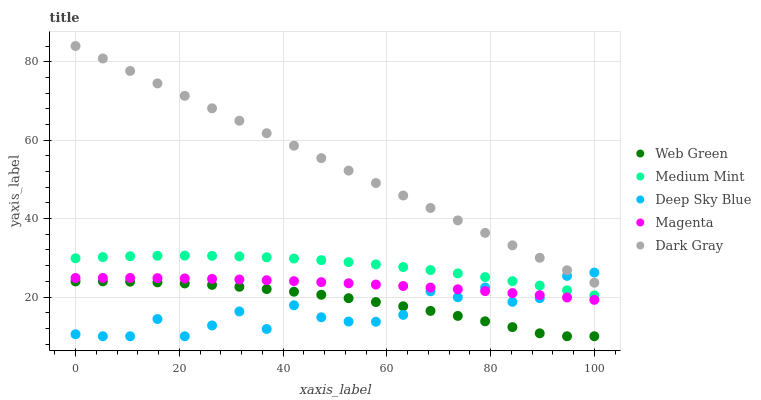Does Deep Sky Blue have the minimum area under the curve?
Answer yes or no. Yes. Does Dark Gray have the maximum area under the curve?
Answer yes or no. Yes. Does Magenta have the minimum area under the curve?
Answer yes or no. No. Does Magenta have the maximum area under the curve?
Answer yes or no. No. Is Dark Gray the smoothest?
Answer yes or no. Yes. Is Deep Sky Blue the roughest?
Answer yes or no. Yes. Is Magenta the smoothest?
Answer yes or no. No. Is Magenta the roughest?
Answer yes or no. No. Does Deep Sky Blue have the lowest value?
Answer yes or no. Yes. Does Magenta have the lowest value?
Answer yes or no. No. Does Dark Gray have the highest value?
Answer yes or no. Yes. Does Magenta have the highest value?
Answer yes or no. No. Is Web Green less than Magenta?
Answer yes or no. Yes. Is Dark Gray greater than Magenta?
Answer yes or no. Yes. Does Dark Gray intersect Deep Sky Blue?
Answer yes or no. Yes. Is Dark Gray less than Deep Sky Blue?
Answer yes or no. No. Is Dark Gray greater than Deep Sky Blue?
Answer yes or no. No. Does Web Green intersect Magenta?
Answer yes or no. No. 